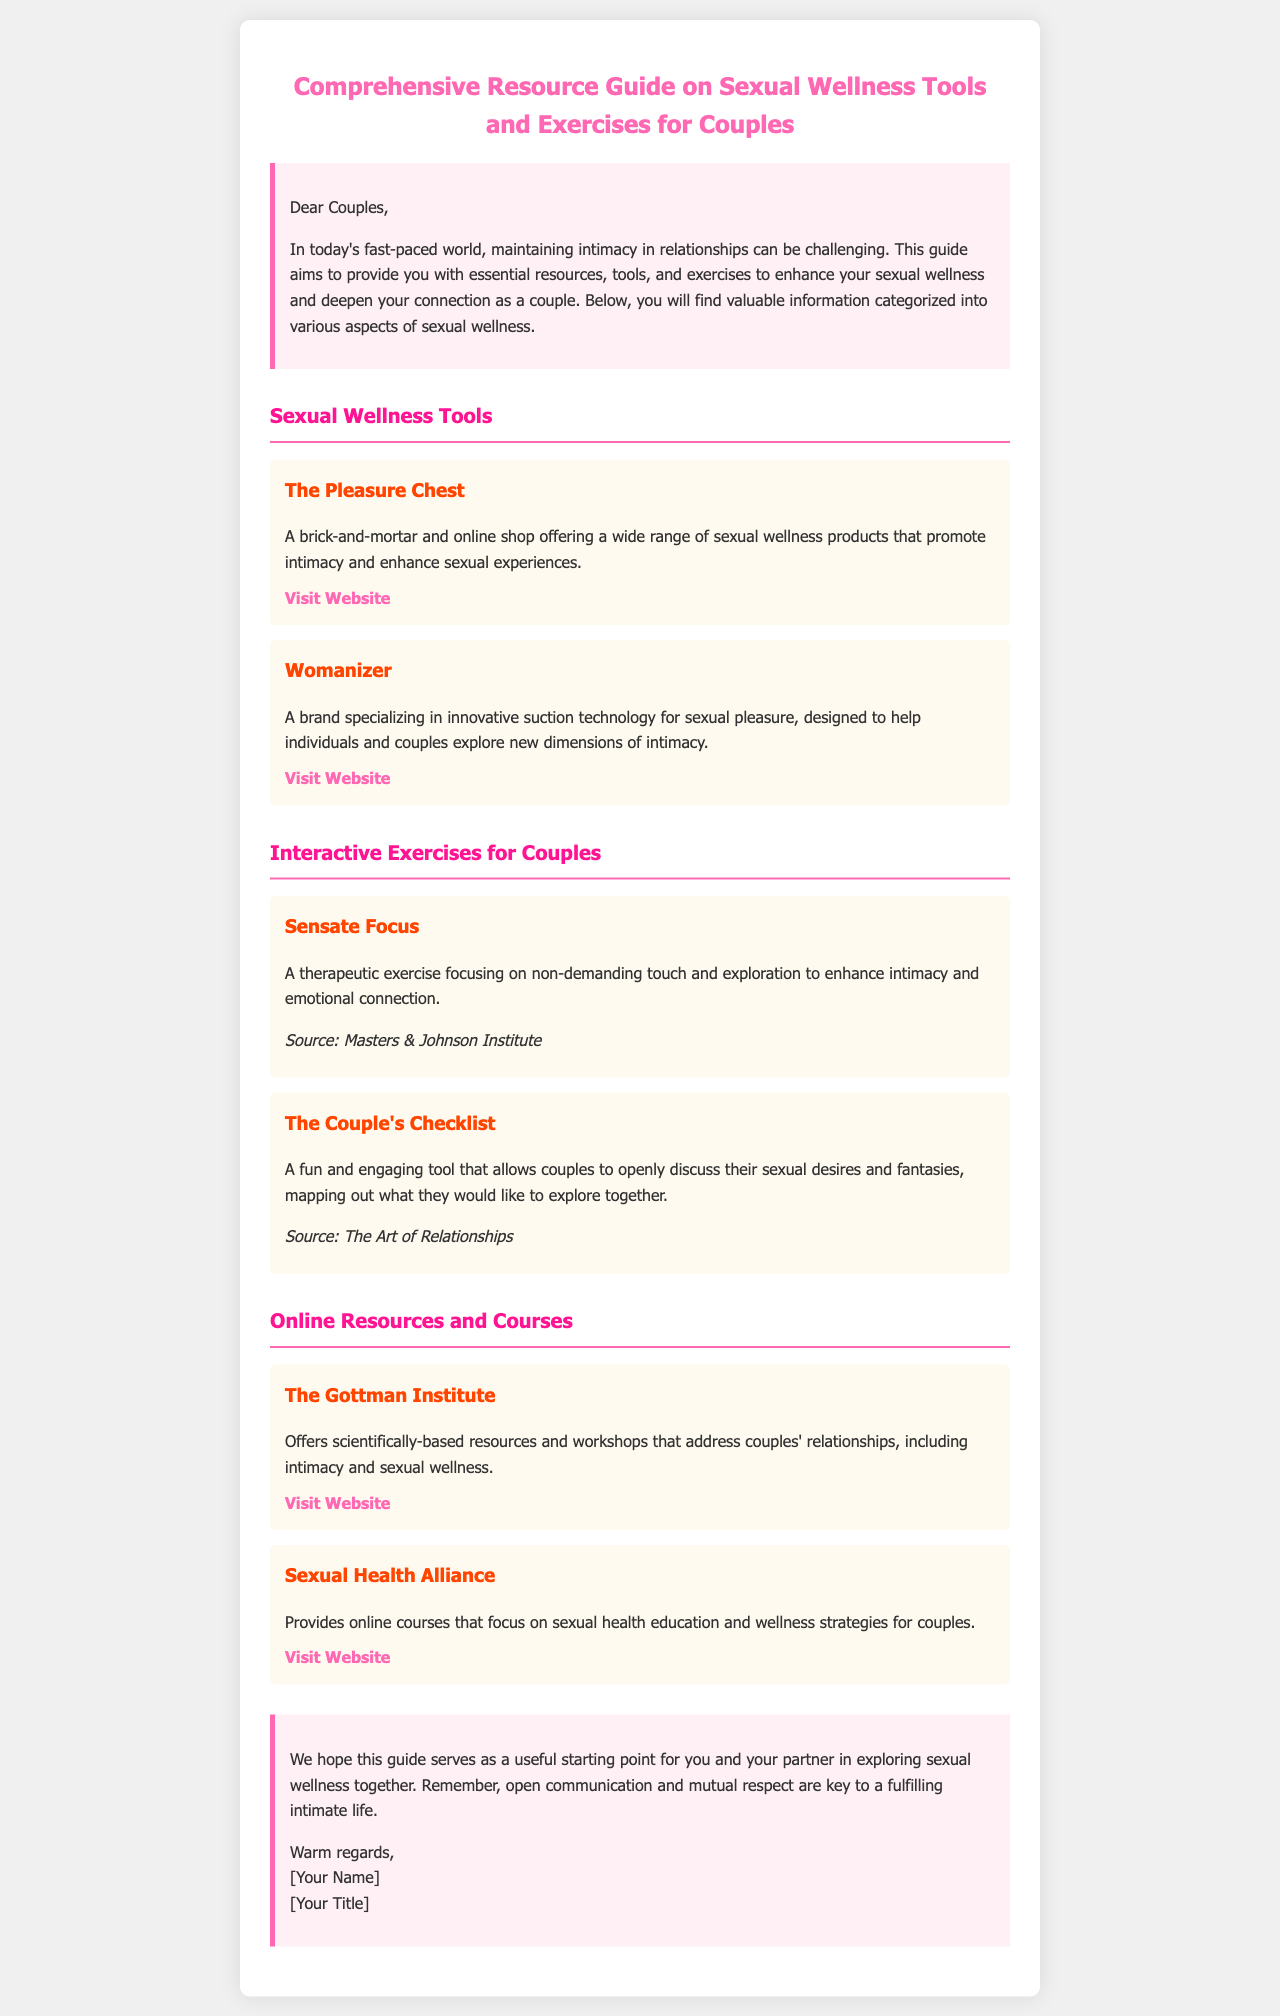What is the title of the document? The title is mentioned in the header of the document.
Answer: Comprehensive Resource Guide on Sexual Wellness Tools and Exercises for Couples What is the purpose of the guide? The introduction summarizes the aim of the guide.
Answer: To enhance sexual wellness and deepen connection Who is the author of the document? The author is mentioned in the closing section of the document.
Answer: [Your Name] What interactive exercise focuses on non-demanding touch? The exercise is listed under the section for interactive exercises.
Answer: Sensate Focus Which online resource offers scientifically-based workshops? The document specifies which online resource provides workshops.
Answer: The Gottman Institute What type of products does The Pleasure Chest offer? The Pleasure Chest's offering is described in the first tools section.
Answer: Sexual wellness products How many exercises for couples are listed in the document? The number of interactive exercises provided can be found in the interactive exercises section.
Answer: Two What color is primarily used for the section headings? The color used for headings can be identified from the styles applied in the document.
Answer: #ff1493 What is emphasized as key to a fulfilling intimate life? The closing remarks note important elements for intimacy.
Answer: Open communication and mutual respect 